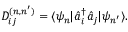Convert formula to latex. <formula><loc_0><loc_0><loc_500><loc_500>D _ { i j } ^ { ( n , n ^ { \prime } ) } = \langle \psi _ { n } | \hat { a } _ { i } ^ { \dagger } \hat { a } _ { j } | \psi _ { n ^ { \prime } } \rangle .</formula> 